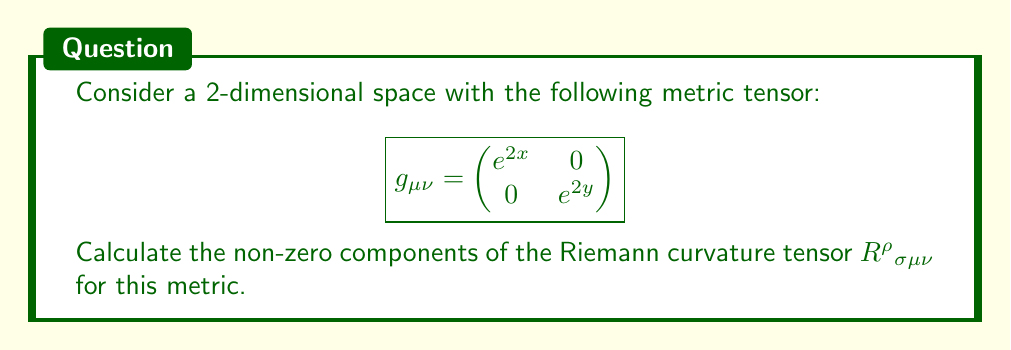Give your solution to this math problem. To calculate the Riemann curvature tensor, we'll follow these steps:

1) First, calculate the Christoffel symbols $\Gamma^\rho_{\mu\nu}$:
   $$\Gamma^\rho_{\mu\nu} = \frac{1}{2}g^{\rho\sigma}(\partial_\mu g_{\nu\sigma} + \partial_\nu g_{\mu\sigma} - \partial_\sigma g_{\mu\nu})$$

   The non-zero Christoffel symbols are:
   $$\Gamma^1_{11} = 1, \quad \Gamma^2_{22} = 1$$

2) Now, use the Riemann tensor formula:
   $$R^\rho{}_{\sigma\mu\nu} = \partial_\mu \Gamma^\rho_{\nu\sigma} - \partial_\nu \Gamma^\rho_{\mu\sigma} + \Gamma^\rho_{\mu\lambda}\Gamma^\lambda_{\nu\sigma} - \Gamma^\rho_{\nu\lambda}\Gamma^\lambda_{\mu\sigma}$$

3) Calculate each non-zero component:

   $R^1{}_{212} = -R^1{}_{221}$:
   $$\begin{aligned}
   R^1{}_{212} &= \partial_1 \Gamma^1_{22} - \partial_2 \Gamma^1_{12} + \Gamma^1_{1\lambda}\Gamma^\lambda_{22} - \Gamma^1_{2\lambda}\Gamma^\lambda_{12} \\
   &= 0 - 0 + \Gamma^1_{11}\Gamma^1_{22} - 0 \\
   &= 1 \cdot 0 = 0
   \end{aligned}$$

   $R^2{}_{121} = -R^2{}_{112}$:
   $$\begin{aligned}
   R^2{}_{121} &= \partial_2 \Gamma^2_{11} - \partial_1 \Gamma^2_{21} + \Gamma^2_{2\lambda}\Gamma^\lambda_{11} - \Gamma^2_{1\lambda}\Gamma^\lambda_{21} \\
   &= 0 - 0 + \Gamma^2_{22}\Gamma^2_{11} - 0 \\
   &= 1 \cdot 0 = 0
   \end{aligned}$$

4) All other components are zero due to symmetry or antisymmetry properties of the Riemann tensor.
Answer: All components of $R^\rho{}_{\sigma\mu\nu}$ are zero for this metric. 